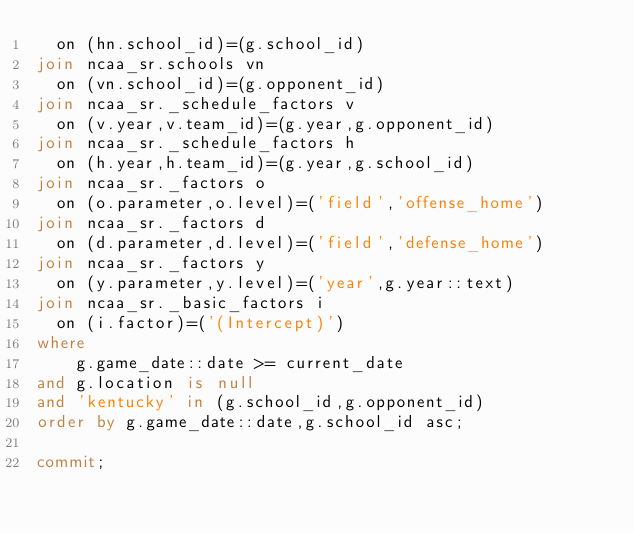Convert code to text. <code><loc_0><loc_0><loc_500><loc_500><_SQL_>  on (hn.school_id)=(g.school_id)
join ncaa_sr.schools vn
  on (vn.school_id)=(g.opponent_id)
join ncaa_sr._schedule_factors v
  on (v.year,v.team_id)=(g.year,g.opponent_id)
join ncaa_sr._schedule_factors h
  on (h.year,h.team_id)=(g.year,g.school_id)
join ncaa_sr._factors o
  on (o.parameter,o.level)=('field','offense_home')
join ncaa_sr._factors d
  on (d.parameter,d.level)=('field','defense_home')
join ncaa_sr._factors y
  on (y.parameter,y.level)=('year',g.year::text)
join ncaa_sr._basic_factors i
  on (i.factor)=('(Intercept)')
where
    g.game_date::date >= current_date
and g.location is null
and 'kentucky' in (g.school_id,g.opponent_id)
order by g.game_date::date,g.school_id asc;

commit;
</code> 